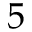Convert formula to latex. <formula><loc_0><loc_0><loc_500><loc_500>5</formula> 